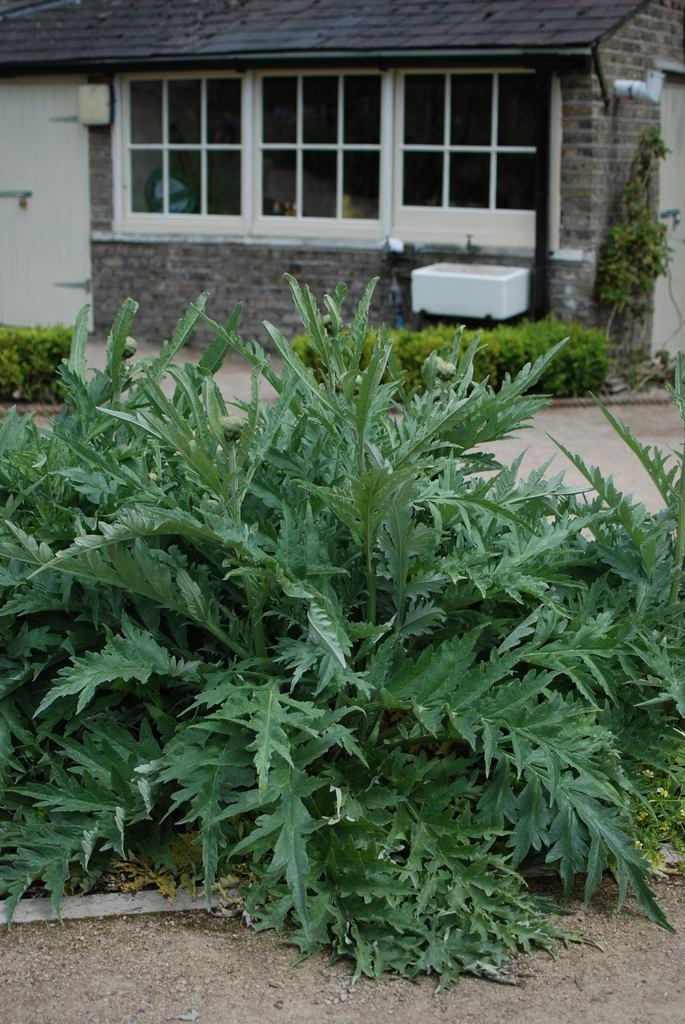What type of vegetation is in the foreground of the image? There are plants in the foreground of the image. What type of structure can be seen in the background of the image? There is a house in the background of the image. What feature of the house is visible in the image? There are windows visible in the background of the image. What can be seen at the bottom of the image? The ground is visible at the bottom of the image. What type of pencil can be seen in the image? There is no pencil present in the image. How many trucks are visible in the image? There are no trucks visible in the image. 